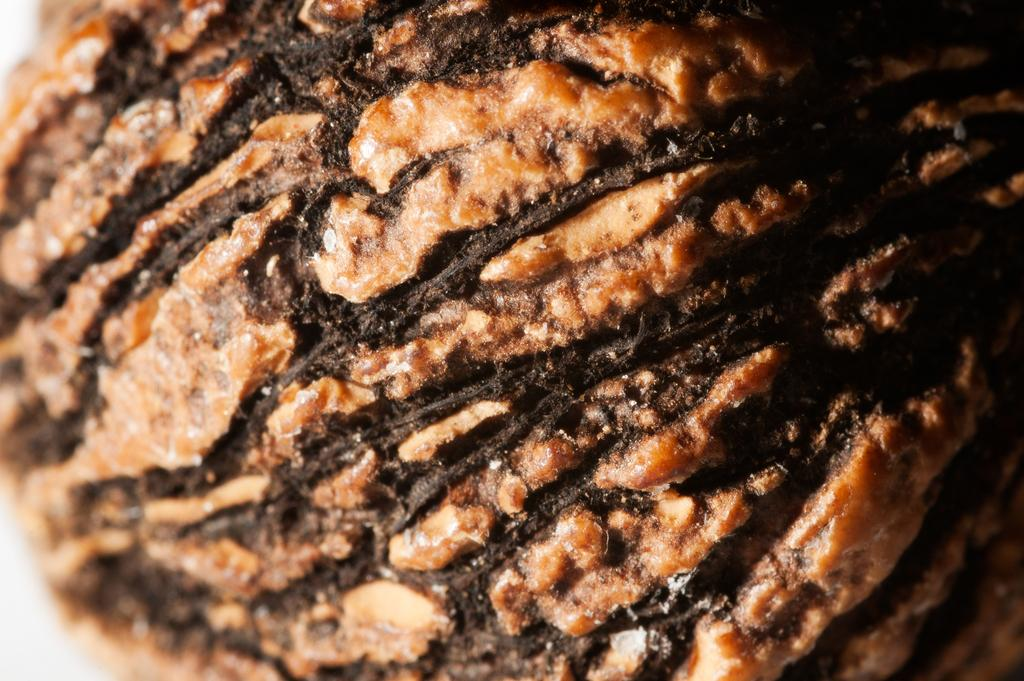What type of food product is visible in the image? There is a food product in the image, but the specific type cannot be determined from the provided facts. What color is the food product in the image? The food product is in brown color, specifically in dark brown color. How many caves can be seen in the image? There are no caves present in the image; it features a food product in dark brown color. What type of thread is used to create the baby's clothing in the image? There is no baby or clothing present in the image; it features a food product in dark brown color. 